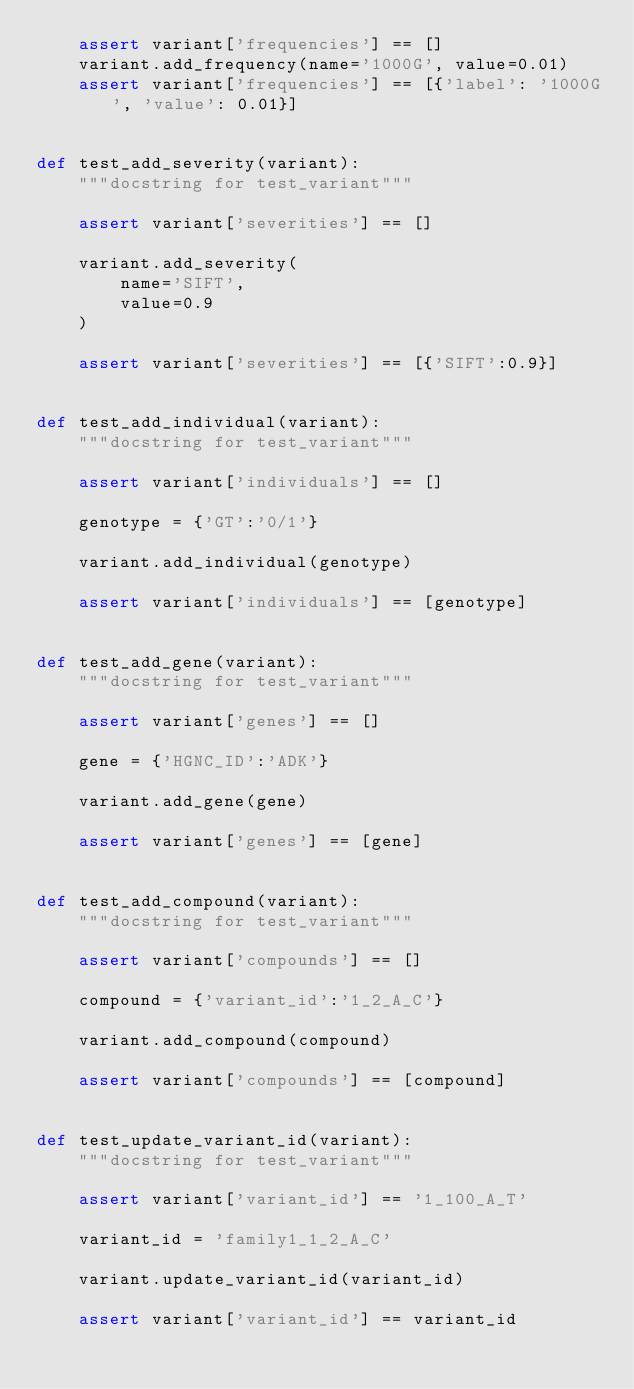<code> <loc_0><loc_0><loc_500><loc_500><_Python_>    assert variant['frequencies'] == []
    variant.add_frequency(name='1000G', value=0.01)
    assert variant['frequencies'] == [{'label': '1000G', 'value': 0.01}]


def test_add_severity(variant):
    """docstring for test_variant"""

    assert variant['severities'] == []

    variant.add_severity(
        name='SIFT',
        value=0.9
    )

    assert variant['severities'] == [{'SIFT':0.9}]


def test_add_individual(variant):
    """docstring for test_variant"""

    assert variant['individuals'] == []

    genotype = {'GT':'0/1'}

    variant.add_individual(genotype)

    assert variant['individuals'] == [genotype]


def test_add_gene(variant):
    """docstring for test_variant"""

    assert variant['genes'] == []

    gene = {'HGNC_ID':'ADK'}

    variant.add_gene(gene)

    assert variant['genes'] == [gene]


def test_add_compound(variant):
    """docstring for test_variant"""

    assert variant['compounds'] == []

    compound = {'variant_id':'1_2_A_C'}

    variant.add_compound(compound)

    assert variant['compounds'] == [compound]


def test_update_variant_id(variant):
    """docstring for test_variant"""

    assert variant['variant_id'] == '1_100_A_T'

    variant_id = 'family1_1_2_A_C'

    variant.update_variant_id(variant_id)

    assert variant['variant_id'] == variant_id
</code> 